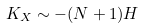<formula> <loc_0><loc_0><loc_500><loc_500>K _ { X } \sim - ( N + 1 ) H</formula> 